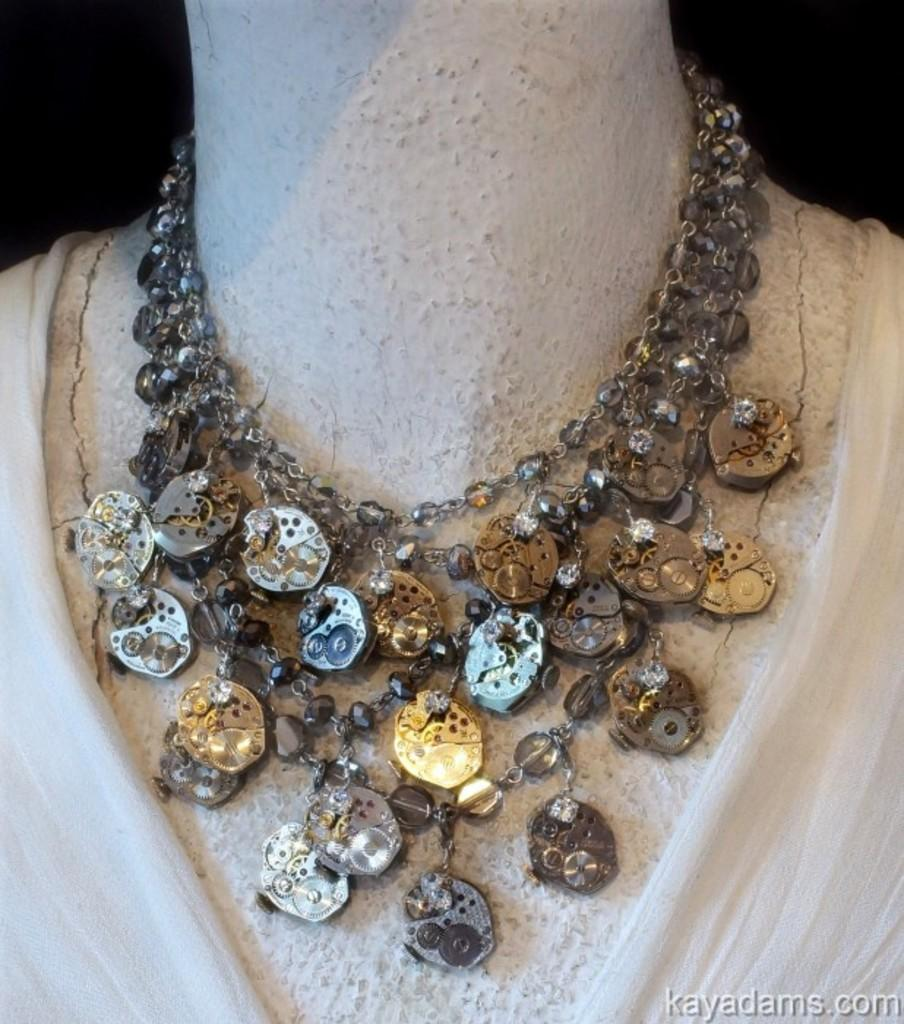What is the main subject of the picture? The main subject of the picture is a mannequin. What is the mannequin wearing in the picture? The mannequin is wearing a necklace in the picture. What type of organization is depicted in the picture? There is no organization depicted in the picture; it features a mannequin wearing a necklace. What is the slope of the terrain in the picture? There is no terrain or slope present in the picture; it is a mannequin wearing a necklace. 